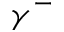<formula> <loc_0><loc_0><loc_500><loc_500>\gamma ^ { - }</formula> 